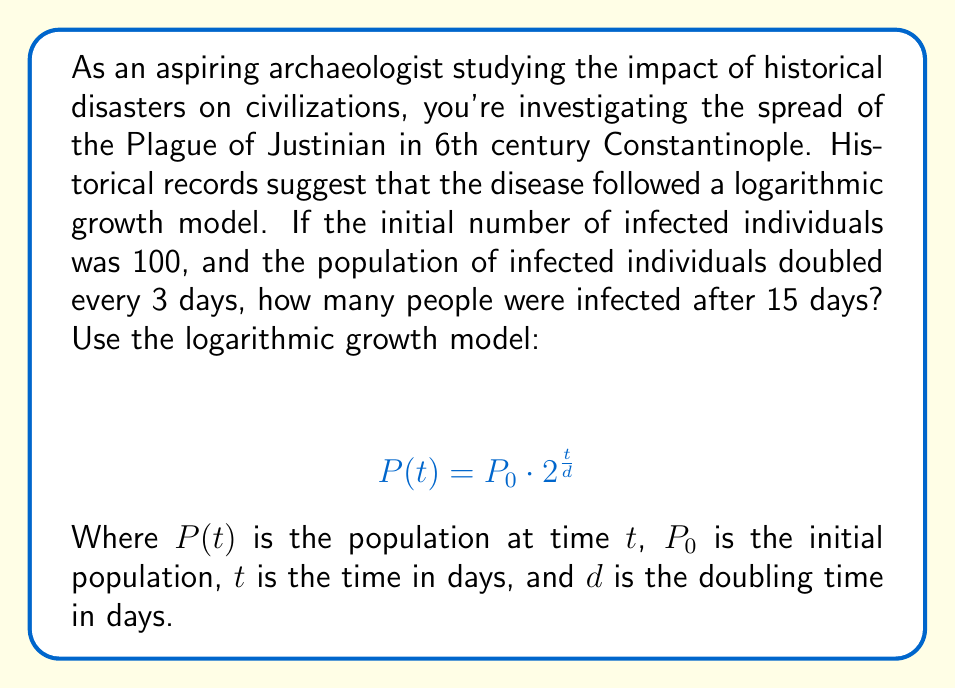Show me your answer to this math problem. To solve this problem, we'll use the given logarithmic growth model and plug in the known values:

$P_0 = 100$ (initial infected population)
$t = 15$ days (time period we're interested in)
$d = 3$ days (doubling time)

Let's substitute these values into the equation:

$$ P(15) = 100 \cdot 2^{\frac{15}{3}} $$

Now, we can simplify the exponent:

$$ P(15) = 100 \cdot 2^5 $$

Calculate $2^5$:

$$ P(15) = 100 \cdot 32 $$

Finally, multiply:

$$ P(15) = 3,200 $$

Therefore, after 15 days, 3,200 people were infected by the Plague of Justinian according to this model.
Answer: 3,200 people 